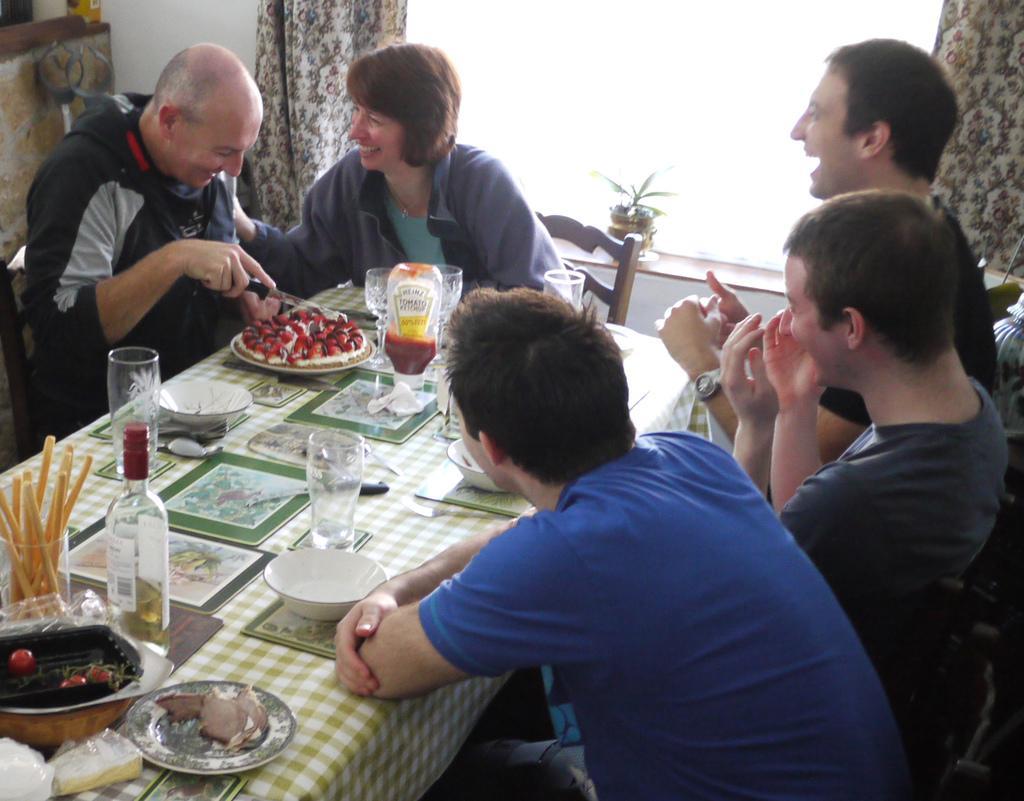Could you give a brief overview of what you see in this image? There are many people sitting on chairs. There is a table. On the table there are glasses, bottle, plates with food item, bowls, ketch up bottle and many other things. In the back there is a window with curtains. On the left side a person is holding a knife. 